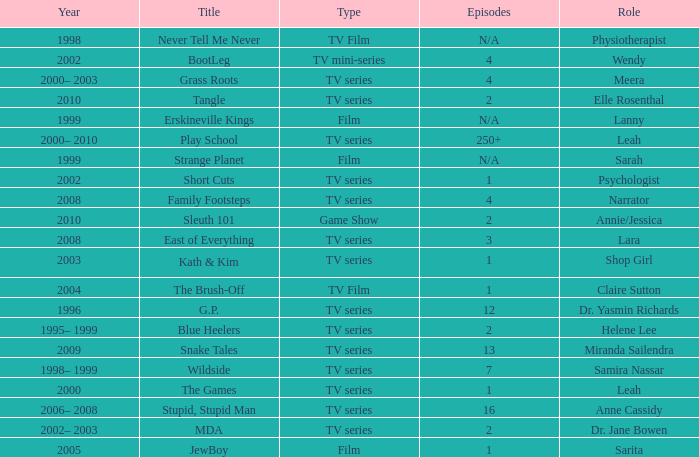What episode is called jewboy 1.0. 